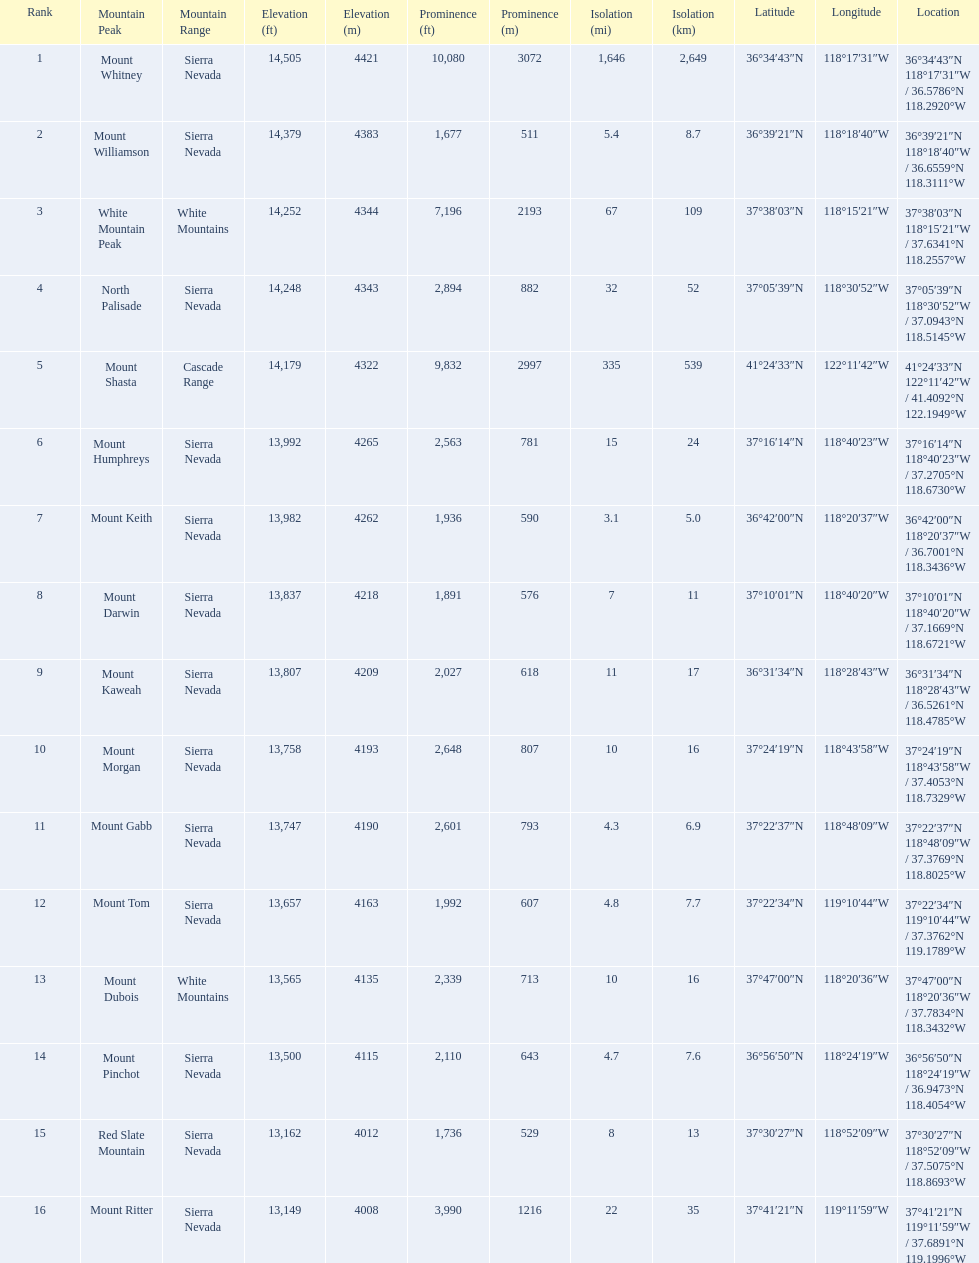What are all of the mountain peaks? Mount Whitney, Mount Williamson, White Mountain Peak, North Palisade, Mount Shasta, Mount Humphreys, Mount Keith, Mount Darwin, Mount Kaweah, Mount Morgan, Mount Gabb, Mount Tom, Mount Dubois, Mount Pinchot, Red Slate Mountain, Mount Ritter. In what ranges are they located? Sierra Nevada, Sierra Nevada, White Mountains, Sierra Nevada, Cascade Range, Sierra Nevada, Sierra Nevada, Sierra Nevada, Sierra Nevada, Sierra Nevada, Sierra Nevada, Sierra Nevada, White Mountains, Sierra Nevada, Sierra Nevada, Sierra Nevada. And which mountain peak is in the cascade range? Mount Shasta. 